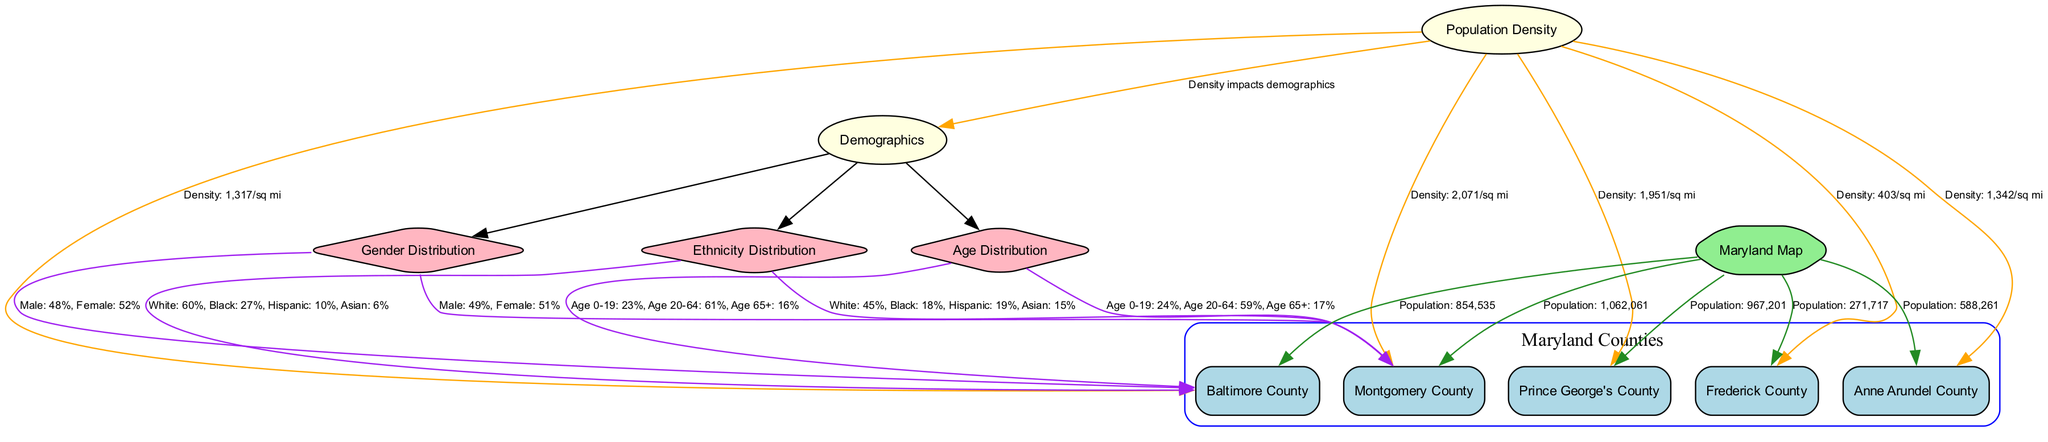What is the population of Montgomery County? The diagram states that the population of Montgomery County is directly connected to the Maryland map node, with a label indicating the population value.
Answer: 1,062,061 What percentage of the population in Baltimore County is aged 65 and older? The age distribution for Baltimore County is given as "Age 0-19: 23%, Age 20-64: 61%, Age 65+: 16%". From this data, the percentage of the population aged 65+ can be identified directly.
Answer: 16% Which county has the highest population density? The diagram shows population density values linked to each county. Analyzing these, Montgomery County has the highest density at "2,071/sq mi".
Answer: Montgomery County What is the male percentage in Prince George's County? The gender distribution for Prince George's County is given as part of the gender distribution data, which specifically lists "Male: 49%, Female: 51%", indicating the male percentage.
Answer: 49% How does population density impact demographics? The edge between the population density and demographics nodes states "Density impacts demographics," indicating that there is an interrelation where higher density influences the demographic distribution in the counties.
Answer: Density impacts demographics What is the total number of counties represented in the diagram? The diagram lists five counties within a subgraph labeled "Maryland Counties". Counting these nodes provides the total number of counties represented.
Answer: 5 What percentage of the population in Montgomery County is Hispanic? The ethnicity distribution for Montgomery County shows "White: 45%, Black: 18%, Hispanic: 19%, Asian: 15%". This allows for the determination of the Hispanic percentage directly from the data provided.
Answer: 19% What is the population density of Frederick County? The diagram provides the density information directly connected to Frederick County with the label "Density: 403/sq mi", allowing for a direct identification of this metric.
Answer: 403/sq mi 